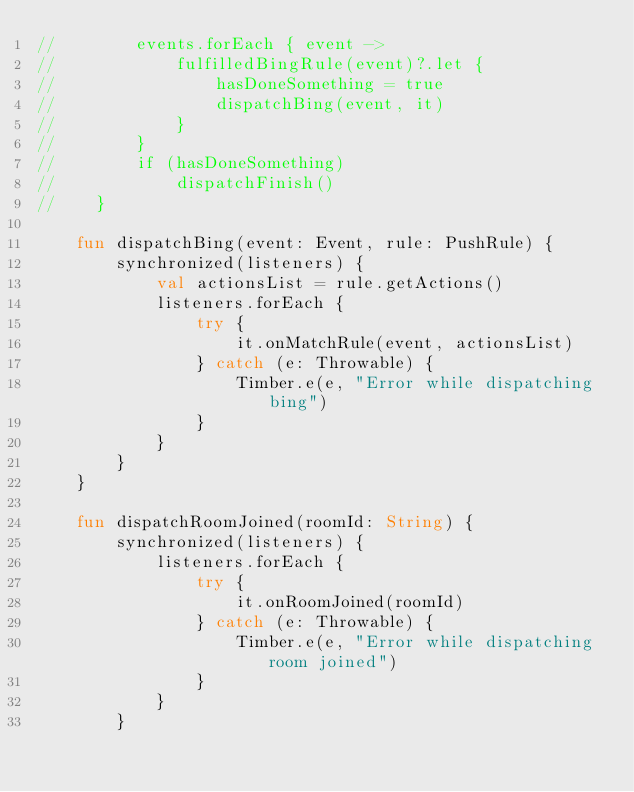Convert code to text. <code><loc_0><loc_0><loc_500><loc_500><_Kotlin_>//        events.forEach { event ->
//            fulfilledBingRule(event)?.let {
//                hasDoneSomething = true
//                dispatchBing(event, it)
//            }
//        }
//        if (hasDoneSomething)
//            dispatchFinish()
//    }

    fun dispatchBing(event: Event, rule: PushRule) {
        synchronized(listeners) {
            val actionsList = rule.getActions()
            listeners.forEach {
                try {
                    it.onMatchRule(event, actionsList)
                } catch (e: Throwable) {
                    Timber.e(e, "Error while dispatching bing")
                }
            }
        }
    }

    fun dispatchRoomJoined(roomId: String) {
        synchronized(listeners) {
            listeners.forEach {
                try {
                    it.onRoomJoined(roomId)
                } catch (e: Throwable) {
                    Timber.e(e, "Error while dispatching room joined")
                }
            }
        }</code> 